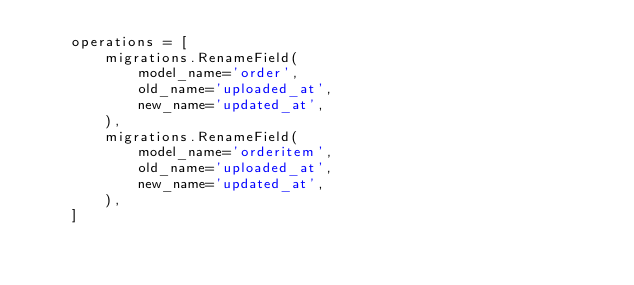Convert code to text. <code><loc_0><loc_0><loc_500><loc_500><_Python_>    operations = [
        migrations.RenameField(
            model_name='order',
            old_name='uploaded_at',
            new_name='updated_at',
        ),
        migrations.RenameField(
            model_name='orderitem',
            old_name='uploaded_at',
            new_name='updated_at',
        ),
    ]
</code> 